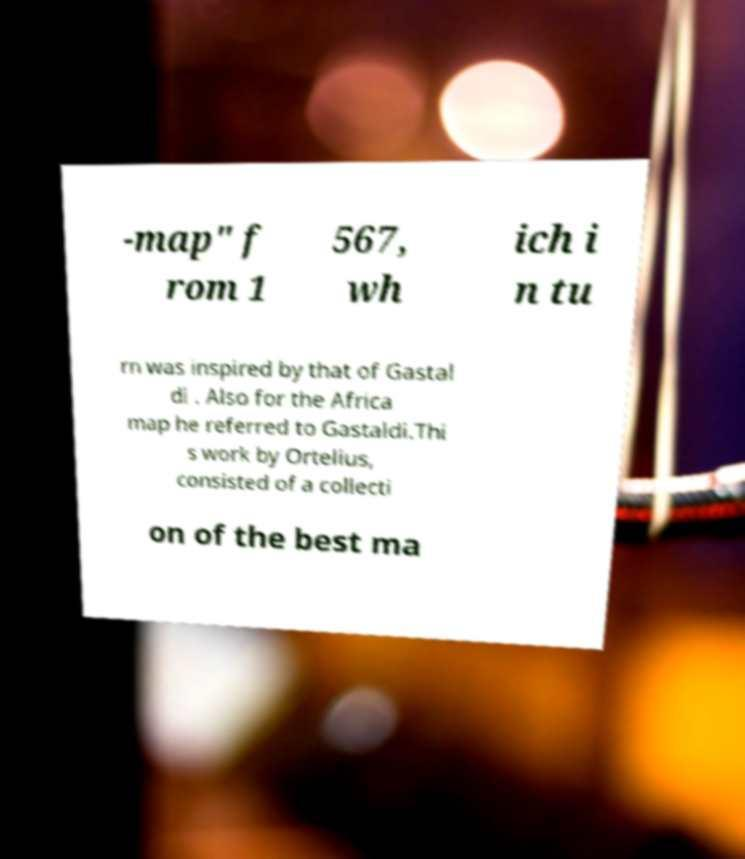Can you accurately transcribe the text from the provided image for me? -map" f rom 1 567, wh ich i n tu rn was inspired by that of Gastal di . Also for the Africa map he referred to Gastaldi.Thi s work by Ortelius, consisted of a collecti on of the best ma 